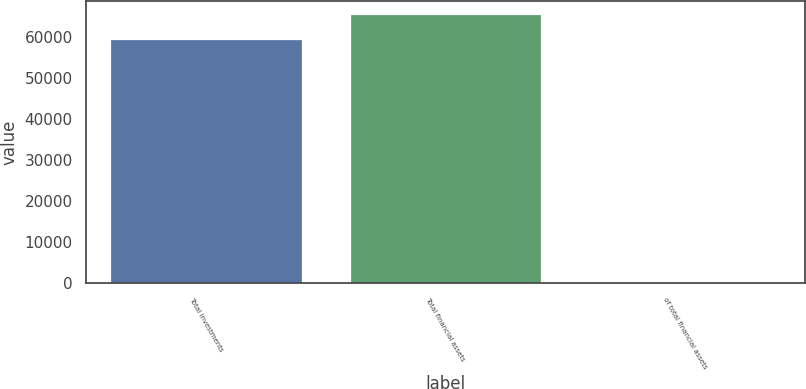Convert chart. <chart><loc_0><loc_0><loc_500><loc_500><bar_chart><fcel>Total investments<fcel>Total financial assets<fcel>of total financial assets<nl><fcel>59536<fcel>65483.9<fcel>57.1<nl></chart> 